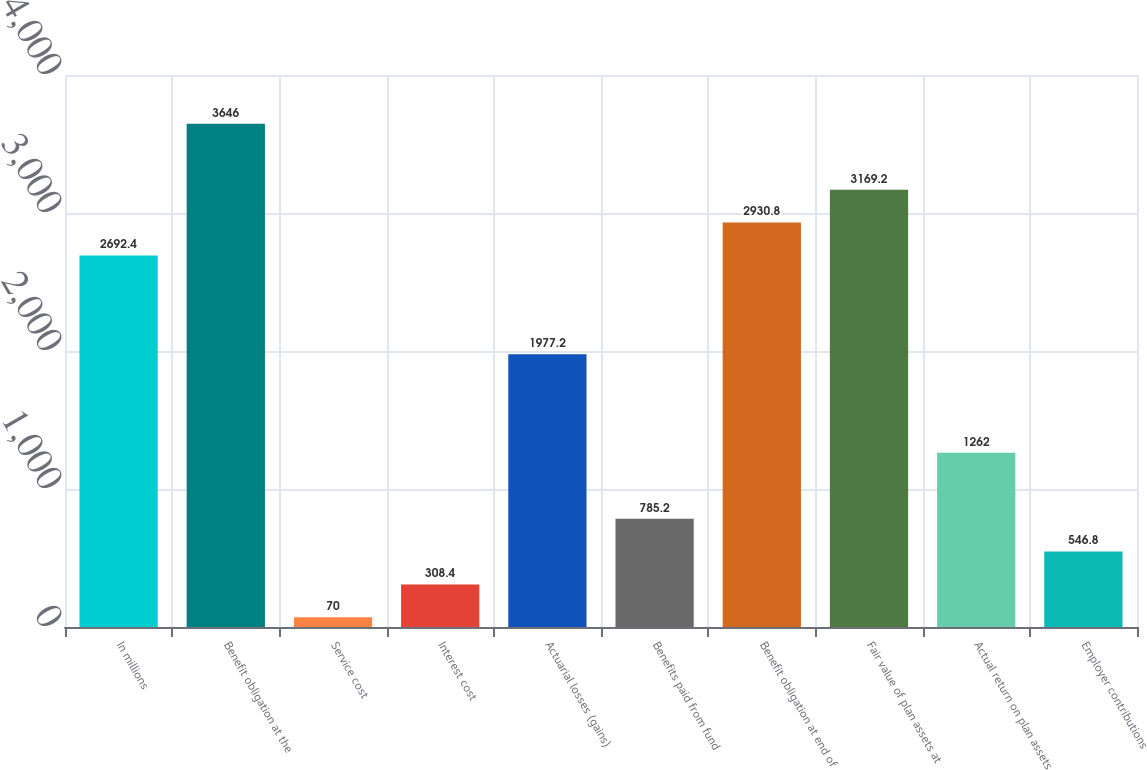Convert chart to OTSL. <chart><loc_0><loc_0><loc_500><loc_500><bar_chart><fcel>In millions<fcel>Benefit obligation at the<fcel>Service cost<fcel>Interest cost<fcel>Actuarial losses (gains)<fcel>Benefits paid from fund<fcel>Benefit obligation at end of<fcel>Fair value of plan assets at<fcel>Actual return on plan assets<fcel>Employer contributions<nl><fcel>2692.4<fcel>3646<fcel>70<fcel>308.4<fcel>1977.2<fcel>785.2<fcel>2930.8<fcel>3169.2<fcel>1262<fcel>546.8<nl></chart> 